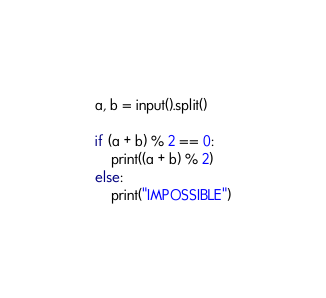Convert code to text. <code><loc_0><loc_0><loc_500><loc_500><_Python_>a, b = input().split()

if (a + b) % 2 == 0:
    print((a + b) % 2)
else:
    print("IMPOSSIBLE")</code> 